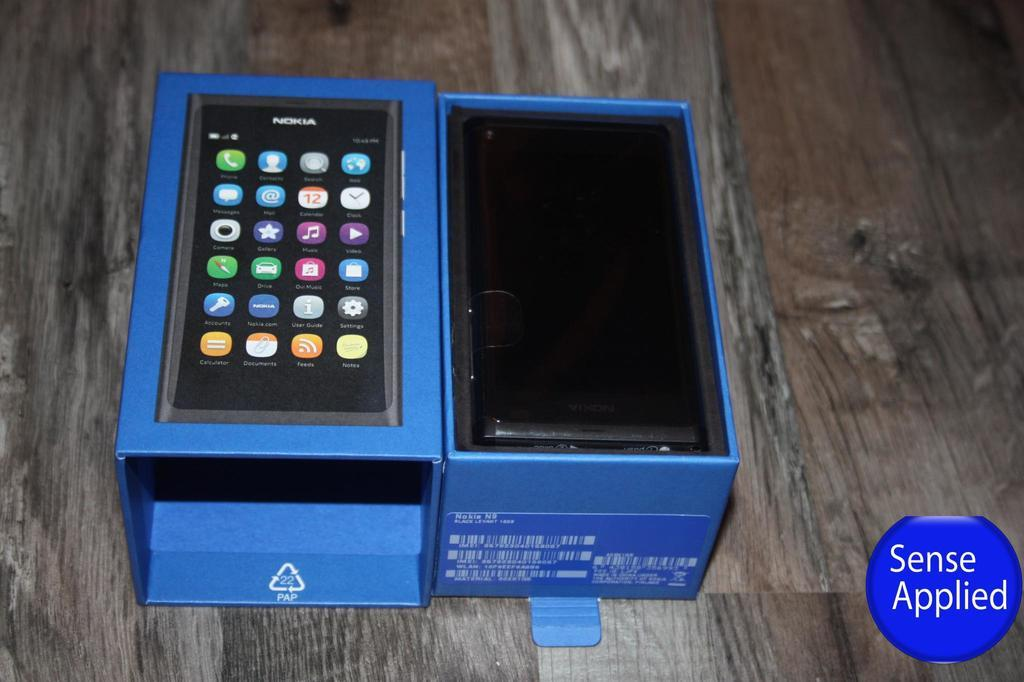Provide a one-sentence caption for the provided image. A blue box that contains a smartphone in it. 